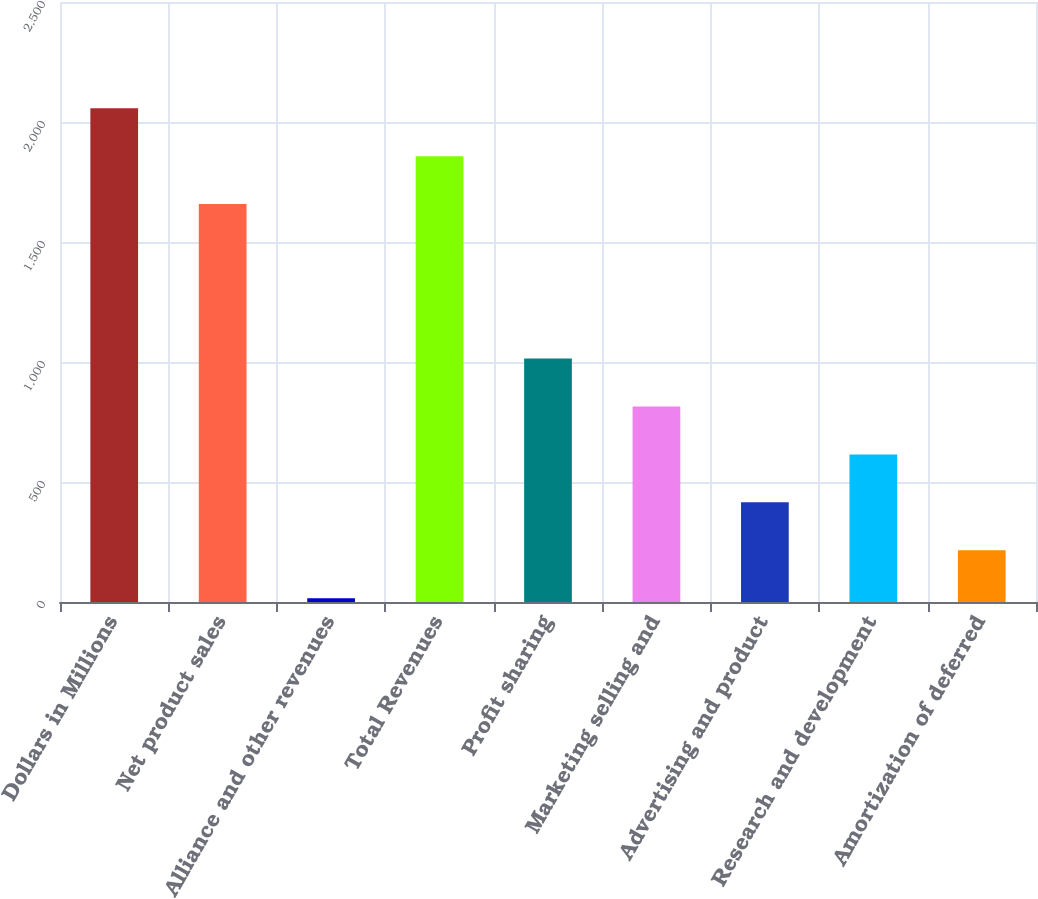Convert chart to OTSL. <chart><loc_0><loc_0><loc_500><loc_500><bar_chart><fcel>Dollars in Millions<fcel>Net product sales<fcel>Alliance and other revenues<fcel>Total Revenues<fcel>Profit sharing<fcel>Marketing selling and<fcel>Advertising and product<fcel>Research and development<fcel>Amortization of deferred<nl><fcel>2057.4<fcel>1658<fcel>16<fcel>1857.7<fcel>1014.5<fcel>814.8<fcel>415.4<fcel>615.1<fcel>215.7<nl></chart> 